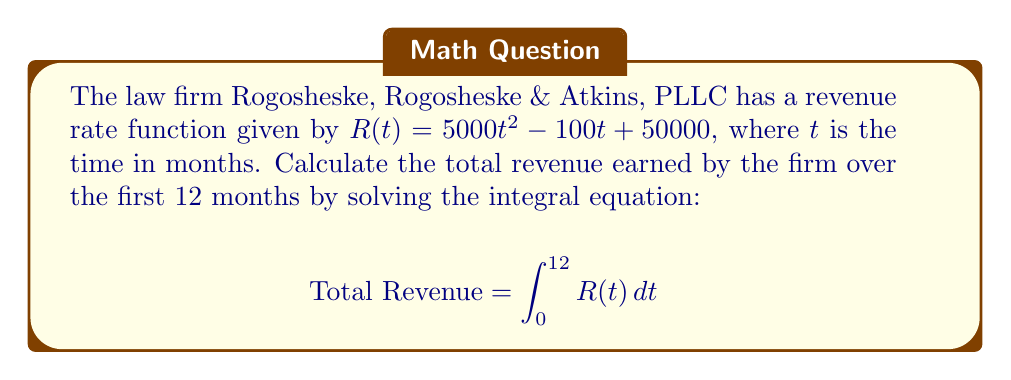What is the answer to this math problem? To solve this integral equation, we'll follow these steps:

1) The revenue rate function is given as:
   $R(t) = 5000t^2 - 100t + 50000$

2) We need to integrate this function from $t=0$ to $t=12$:
   $$\text{Total Revenue} = \int_0^{12} (5000t^2 - 100t + 50000) dt$$

3) Let's integrate each term separately:
   $$\int_0^{12} 5000t^2 dt = 5000 \cdot \frac{t^3}{3} \bigg|_0^{12}$$
   $$\int_0^{12} -100t dt = -100 \cdot \frac{t^2}{2} \bigg|_0^{12}$$
   $$\int_0^{12} 50000 dt = 50000t \bigg|_0^{12}$$

4) Now, let's evaluate each term:
   $$5000 \cdot \frac{t^3}{3} \bigg|_0^{12} = 5000 \cdot \frac{12^3}{3} - 0 = 2,880,000$$
   $$-100 \cdot \frac{t^2}{2} \bigg|_0^{12} = -100 \cdot \frac{12^2}{2} - 0 = -7,200$$
   $$50000t \bigg|_0^{12} = 50000 \cdot 12 - 0 = 600,000$$

5) Sum up all the terms:
   $$\text{Total Revenue} = 2,880,000 - 7,200 + 600,000 = 3,472,800$$

Therefore, the total revenue earned by Rogosheske, Rogosheske & Atkins, PLLC over the first 12 months is $3,472,800.
Answer: $3,472,800 